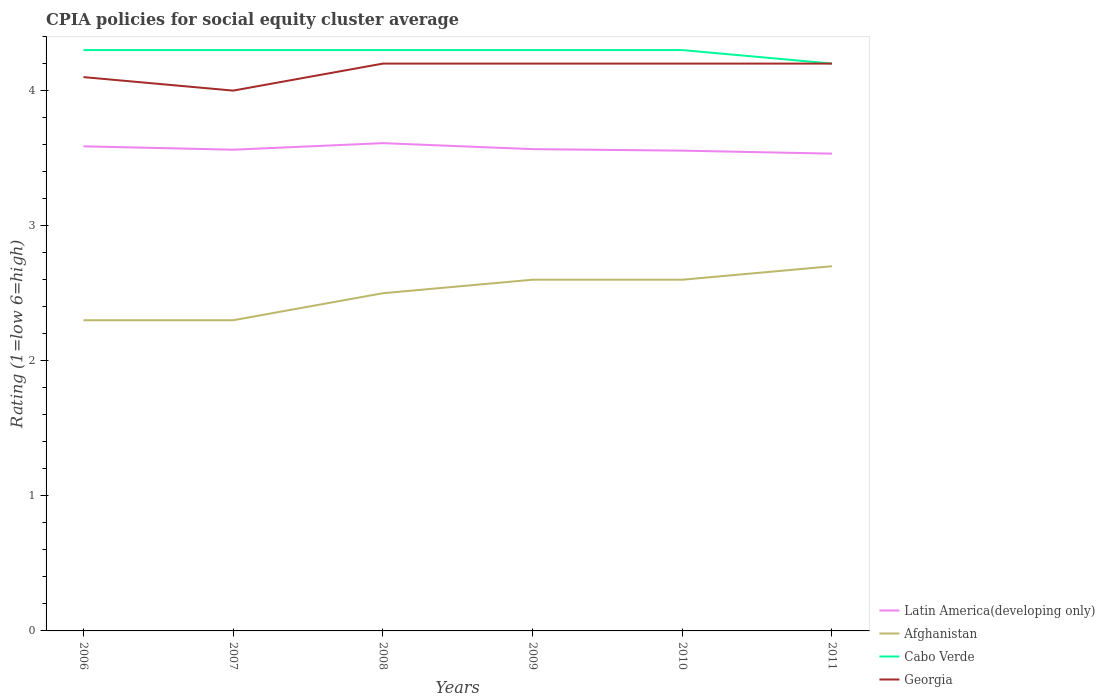How many different coloured lines are there?
Offer a terse response. 4. Does the line corresponding to Latin America(developing only) intersect with the line corresponding to Cabo Verde?
Your answer should be very brief. No. Is the number of lines equal to the number of legend labels?
Offer a terse response. Yes. Across all years, what is the maximum CPIA rating in Georgia?
Provide a succinct answer. 4. What is the difference between the highest and the second highest CPIA rating in Georgia?
Offer a terse response. 0.2. What is the difference between the highest and the lowest CPIA rating in Afghanistan?
Keep it short and to the point. 3. Is the CPIA rating in Cabo Verde strictly greater than the CPIA rating in Georgia over the years?
Ensure brevity in your answer.  No. How many lines are there?
Offer a terse response. 4. Are the values on the major ticks of Y-axis written in scientific E-notation?
Provide a short and direct response. No. Does the graph contain grids?
Your response must be concise. No. Where does the legend appear in the graph?
Provide a succinct answer. Bottom right. What is the title of the graph?
Your answer should be compact. CPIA policies for social equity cluster average. Does "Kuwait" appear as one of the legend labels in the graph?
Make the answer very short. No. What is the label or title of the Y-axis?
Offer a very short reply. Rating (1=low 6=high). What is the Rating (1=low 6=high) in Latin America(developing only) in 2006?
Your answer should be compact. 3.59. What is the Rating (1=low 6=high) in Latin America(developing only) in 2007?
Ensure brevity in your answer.  3.56. What is the Rating (1=low 6=high) in Cabo Verde in 2007?
Your response must be concise. 4.3. What is the Rating (1=low 6=high) in Latin America(developing only) in 2008?
Provide a short and direct response. 3.61. What is the Rating (1=low 6=high) in Afghanistan in 2008?
Offer a terse response. 2.5. What is the Rating (1=low 6=high) in Georgia in 2008?
Provide a short and direct response. 4.2. What is the Rating (1=low 6=high) of Latin America(developing only) in 2009?
Offer a very short reply. 3.57. What is the Rating (1=low 6=high) of Afghanistan in 2009?
Keep it short and to the point. 2.6. What is the Rating (1=low 6=high) of Cabo Verde in 2009?
Keep it short and to the point. 4.3. What is the Rating (1=low 6=high) in Georgia in 2009?
Give a very brief answer. 4.2. What is the Rating (1=low 6=high) in Latin America(developing only) in 2010?
Offer a terse response. 3.56. What is the Rating (1=low 6=high) in Cabo Verde in 2010?
Make the answer very short. 4.3. What is the Rating (1=low 6=high) of Georgia in 2010?
Provide a short and direct response. 4.2. What is the Rating (1=low 6=high) of Latin America(developing only) in 2011?
Provide a succinct answer. 3.53. What is the Rating (1=low 6=high) in Afghanistan in 2011?
Keep it short and to the point. 2.7. What is the Rating (1=low 6=high) of Cabo Verde in 2011?
Provide a succinct answer. 4.2. What is the Rating (1=low 6=high) in Georgia in 2011?
Give a very brief answer. 4.2. Across all years, what is the maximum Rating (1=low 6=high) of Latin America(developing only)?
Make the answer very short. 3.61. Across all years, what is the maximum Rating (1=low 6=high) of Afghanistan?
Your response must be concise. 2.7. Across all years, what is the minimum Rating (1=low 6=high) of Latin America(developing only)?
Your answer should be very brief. 3.53. Across all years, what is the minimum Rating (1=low 6=high) of Cabo Verde?
Your answer should be very brief. 4.2. Across all years, what is the minimum Rating (1=low 6=high) of Georgia?
Provide a short and direct response. 4. What is the total Rating (1=low 6=high) in Latin America(developing only) in the graph?
Your response must be concise. 21.42. What is the total Rating (1=low 6=high) of Afghanistan in the graph?
Offer a terse response. 15. What is the total Rating (1=low 6=high) in Cabo Verde in the graph?
Give a very brief answer. 25.7. What is the total Rating (1=low 6=high) of Georgia in the graph?
Offer a terse response. 24.9. What is the difference between the Rating (1=low 6=high) of Latin America(developing only) in 2006 and that in 2007?
Your answer should be very brief. 0.03. What is the difference between the Rating (1=low 6=high) of Georgia in 2006 and that in 2007?
Give a very brief answer. 0.1. What is the difference between the Rating (1=low 6=high) in Latin America(developing only) in 2006 and that in 2008?
Your answer should be compact. -0.02. What is the difference between the Rating (1=low 6=high) of Cabo Verde in 2006 and that in 2008?
Your answer should be compact. 0. What is the difference between the Rating (1=low 6=high) in Latin America(developing only) in 2006 and that in 2009?
Your response must be concise. 0.02. What is the difference between the Rating (1=low 6=high) of Cabo Verde in 2006 and that in 2009?
Your answer should be very brief. 0. What is the difference between the Rating (1=low 6=high) of Georgia in 2006 and that in 2009?
Your response must be concise. -0.1. What is the difference between the Rating (1=low 6=high) in Latin America(developing only) in 2006 and that in 2010?
Provide a short and direct response. 0.03. What is the difference between the Rating (1=low 6=high) of Afghanistan in 2006 and that in 2010?
Your response must be concise. -0.3. What is the difference between the Rating (1=low 6=high) of Latin America(developing only) in 2006 and that in 2011?
Your answer should be very brief. 0.05. What is the difference between the Rating (1=low 6=high) of Afghanistan in 2006 and that in 2011?
Offer a very short reply. -0.4. What is the difference between the Rating (1=low 6=high) of Cabo Verde in 2006 and that in 2011?
Your answer should be very brief. 0.1. What is the difference between the Rating (1=low 6=high) of Georgia in 2006 and that in 2011?
Your answer should be compact. -0.1. What is the difference between the Rating (1=low 6=high) of Latin America(developing only) in 2007 and that in 2008?
Ensure brevity in your answer.  -0.05. What is the difference between the Rating (1=low 6=high) in Afghanistan in 2007 and that in 2008?
Make the answer very short. -0.2. What is the difference between the Rating (1=low 6=high) in Latin America(developing only) in 2007 and that in 2009?
Offer a terse response. -0. What is the difference between the Rating (1=low 6=high) in Afghanistan in 2007 and that in 2009?
Ensure brevity in your answer.  -0.3. What is the difference between the Rating (1=low 6=high) of Georgia in 2007 and that in 2009?
Offer a terse response. -0.2. What is the difference between the Rating (1=low 6=high) of Latin America(developing only) in 2007 and that in 2010?
Provide a succinct answer. 0.01. What is the difference between the Rating (1=low 6=high) of Afghanistan in 2007 and that in 2010?
Your answer should be compact. -0.3. What is the difference between the Rating (1=low 6=high) in Cabo Verde in 2007 and that in 2010?
Give a very brief answer. 0. What is the difference between the Rating (1=low 6=high) of Georgia in 2007 and that in 2010?
Offer a terse response. -0.2. What is the difference between the Rating (1=low 6=high) in Latin America(developing only) in 2007 and that in 2011?
Your response must be concise. 0.03. What is the difference between the Rating (1=low 6=high) in Afghanistan in 2007 and that in 2011?
Keep it short and to the point. -0.4. What is the difference between the Rating (1=low 6=high) in Georgia in 2007 and that in 2011?
Offer a terse response. -0.2. What is the difference between the Rating (1=low 6=high) of Latin America(developing only) in 2008 and that in 2009?
Provide a short and direct response. 0.04. What is the difference between the Rating (1=low 6=high) in Cabo Verde in 2008 and that in 2009?
Your response must be concise. 0. What is the difference between the Rating (1=low 6=high) in Latin America(developing only) in 2008 and that in 2010?
Your response must be concise. 0.06. What is the difference between the Rating (1=low 6=high) of Afghanistan in 2008 and that in 2010?
Provide a succinct answer. -0.1. What is the difference between the Rating (1=low 6=high) of Georgia in 2008 and that in 2010?
Keep it short and to the point. 0. What is the difference between the Rating (1=low 6=high) of Latin America(developing only) in 2008 and that in 2011?
Give a very brief answer. 0.08. What is the difference between the Rating (1=low 6=high) in Afghanistan in 2008 and that in 2011?
Ensure brevity in your answer.  -0.2. What is the difference between the Rating (1=low 6=high) of Georgia in 2008 and that in 2011?
Make the answer very short. 0. What is the difference between the Rating (1=low 6=high) in Latin America(developing only) in 2009 and that in 2010?
Your answer should be compact. 0.01. What is the difference between the Rating (1=low 6=high) of Afghanistan in 2009 and that in 2010?
Your answer should be very brief. 0. What is the difference between the Rating (1=low 6=high) in Cabo Verde in 2009 and that in 2010?
Keep it short and to the point. 0. What is the difference between the Rating (1=low 6=high) in Latin America(developing only) in 2010 and that in 2011?
Make the answer very short. 0.02. What is the difference between the Rating (1=low 6=high) of Latin America(developing only) in 2006 and the Rating (1=low 6=high) of Afghanistan in 2007?
Offer a terse response. 1.29. What is the difference between the Rating (1=low 6=high) in Latin America(developing only) in 2006 and the Rating (1=low 6=high) in Cabo Verde in 2007?
Ensure brevity in your answer.  -0.71. What is the difference between the Rating (1=low 6=high) in Latin America(developing only) in 2006 and the Rating (1=low 6=high) in Georgia in 2007?
Provide a succinct answer. -0.41. What is the difference between the Rating (1=low 6=high) in Afghanistan in 2006 and the Rating (1=low 6=high) in Cabo Verde in 2007?
Ensure brevity in your answer.  -2. What is the difference between the Rating (1=low 6=high) in Afghanistan in 2006 and the Rating (1=low 6=high) in Georgia in 2007?
Keep it short and to the point. -1.7. What is the difference between the Rating (1=low 6=high) of Cabo Verde in 2006 and the Rating (1=low 6=high) of Georgia in 2007?
Make the answer very short. 0.3. What is the difference between the Rating (1=low 6=high) of Latin America(developing only) in 2006 and the Rating (1=low 6=high) of Afghanistan in 2008?
Ensure brevity in your answer.  1.09. What is the difference between the Rating (1=low 6=high) in Latin America(developing only) in 2006 and the Rating (1=low 6=high) in Cabo Verde in 2008?
Ensure brevity in your answer.  -0.71. What is the difference between the Rating (1=low 6=high) of Latin America(developing only) in 2006 and the Rating (1=low 6=high) of Georgia in 2008?
Offer a terse response. -0.61. What is the difference between the Rating (1=low 6=high) in Afghanistan in 2006 and the Rating (1=low 6=high) in Cabo Verde in 2008?
Offer a terse response. -2. What is the difference between the Rating (1=low 6=high) in Afghanistan in 2006 and the Rating (1=low 6=high) in Georgia in 2008?
Your answer should be very brief. -1.9. What is the difference between the Rating (1=low 6=high) of Cabo Verde in 2006 and the Rating (1=low 6=high) of Georgia in 2008?
Your answer should be compact. 0.1. What is the difference between the Rating (1=low 6=high) in Latin America(developing only) in 2006 and the Rating (1=low 6=high) in Afghanistan in 2009?
Ensure brevity in your answer.  0.99. What is the difference between the Rating (1=low 6=high) of Latin America(developing only) in 2006 and the Rating (1=low 6=high) of Cabo Verde in 2009?
Give a very brief answer. -0.71. What is the difference between the Rating (1=low 6=high) of Latin America(developing only) in 2006 and the Rating (1=low 6=high) of Georgia in 2009?
Give a very brief answer. -0.61. What is the difference between the Rating (1=low 6=high) in Latin America(developing only) in 2006 and the Rating (1=low 6=high) in Afghanistan in 2010?
Keep it short and to the point. 0.99. What is the difference between the Rating (1=low 6=high) of Latin America(developing only) in 2006 and the Rating (1=low 6=high) of Cabo Verde in 2010?
Give a very brief answer. -0.71. What is the difference between the Rating (1=low 6=high) in Latin America(developing only) in 2006 and the Rating (1=low 6=high) in Georgia in 2010?
Ensure brevity in your answer.  -0.61. What is the difference between the Rating (1=low 6=high) in Afghanistan in 2006 and the Rating (1=low 6=high) in Cabo Verde in 2010?
Your response must be concise. -2. What is the difference between the Rating (1=low 6=high) in Cabo Verde in 2006 and the Rating (1=low 6=high) in Georgia in 2010?
Provide a short and direct response. 0.1. What is the difference between the Rating (1=low 6=high) of Latin America(developing only) in 2006 and the Rating (1=low 6=high) of Afghanistan in 2011?
Give a very brief answer. 0.89. What is the difference between the Rating (1=low 6=high) of Latin America(developing only) in 2006 and the Rating (1=low 6=high) of Cabo Verde in 2011?
Your answer should be very brief. -0.61. What is the difference between the Rating (1=low 6=high) of Latin America(developing only) in 2006 and the Rating (1=low 6=high) of Georgia in 2011?
Make the answer very short. -0.61. What is the difference between the Rating (1=low 6=high) in Afghanistan in 2006 and the Rating (1=low 6=high) in Cabo Verde in 2011?
Your answer should be compact. -1.9. What is the difference between the Rating (1=low 6=high) in Afghanistan in 2006 and the Rating (1=low 6=high) in Georgia in 2011?
Give a very brief answer. -1.9. What is the difference between the Rating (1=low 6=high) of Cabo Verde in 2006 and the Rating (1=low 6=high) of Georgia in 2011?
Your answer should be very brief. 0.1. What is the difference between the Rating (1=low 6=high) of Latin America(developing only) in 2007 and the Rating (1=low 6=high) of Afghanistan in 2008?
Offer a very short reply. 1.06. What is the difference between the Rating (1=low 6=high) in Latin America(developing only) in 2007 and the Rating (1=low 6=high) in Cabo Verde in 2008?
Your answer should be very brief. -0.74. What is the difference between the Rating (1=low 6=high) of Latin America(developing only) in 2007 and the Rating (1=low 6=high) of Georgia in 2008?
Offer a very short reply. -0.64. What is the difference between the Rating (1=low 6=high) of Afghanistan in 2007 and the Rating (1=low 6=high) of Cabo Verde in 2008?
Offer a terse response. -2. What is the difference between the Rating (1=low 6=high) of Latin America(developing only) in 2007 and the Rating (1=low 6=high) of Afghanistan in 2009?
Provide a short and direct response. 0.96. What is the difference between the Rating (1=low 6=high) of Latin America(developing only) in 2007 and the Rating (1=low 6=high) of Cabo Verde in 2009?
Make the answer very short. -0.74. What is the difference between the Rating (1=low 6=high) in Latin America(developing only) in 2007 and the Rating (1=low 6=high) in Georgia in 2009?
Provide a short and direct response. -0.64. What is the difference between the Rating (1=low 6=high) of Afghanistan in 2007 and the Rating (1=low 6=high) of Georgia in 2009?
Ensure brevity in your answer.  -1.9. What is the difference between the Rating (1=low 6=high) in Latin America(developing only) in 2007 and the Rating (1=low 6=high) in Afghanistan in 2010?
Provide a short and direct response. 0.96. What is the difference between the Rating (1=low 6=high) in Latin America(developing only) in 2007 and the Rating (1=low 6=high) in Cabo Verde in 2010?
Provide a succinct answer. -0.74. What is the difference between the Rating (1=low 6=high) of Latin America(developing only) in 2007 and the Rating (1=low 6=high) of Georgia in 2010?
Keep it short and to the point. -0.64. What is the difference between the Rating (1=low 6=high) in Afghanistan in 2007 and the Rating (1=low 6=high) in Cabo Verde in 2010?
Provide a short and direct response. -2. What is the difference between the Rating (1=low 6=high) in Cabo Verde in 2007 and the Rating (1=low 6=high) in Georgia in 2010?
Offer a very short reply. 0.1. What is the difference between the Rating (1=low 6=high) of Latin America(developing only) in 2007 and the Rating (1=low 6=high) of Afghanistan in 2011?
Keep it short and to the point. 0.86. What is the difference between the Rating (1=low 6=high) in Latin America(developing only) in 2007 and the Rating (1=low 6=high) in Cabo Verde in 2011?
Make the answer very short. -0.64. What is the difference between the Rating (1=low 6=high) of Latin America(developing only) in 2007 and the Rating (1=low 6=high) of Georgia in 2011?
Offer a very short reply. -0.64. What is the difference between the Rating (1=low 6=high) of Afghanistan in 2007 and the Rating (1=low 6=high) of Cabo Verde in 2011?
Offer a terse response. -1.9. What is the difference between the Rating (1=low 6=high) in Afghanistan in 2007 and the Rating (1=low 6=high) in Georgia in 2011?
Your answer should be compact. -1.9. What is the difference between the Rating (1=low 6=high) in Latin America(developing only) in 2008 and the Rating (1=low 6=high) in Afghanistan in 2009?
Provide a short and direct response. 1.01. What is the difference between the Rating (1=low 6=high) in Latin America(developing only) in 2008 and the Rating (1=low 6=high) in Cabo Verde in 2009?
Make the answer very short. -0.69. What is the difference between the Rating (1=low 6=high) of Latin America(developing only) in 2008 and the Rating (1=low 6=high) of Georgia in 2009?
Your answer should be very brief. -0.59. What is the difference between the Rating (1=low 6=high) of Afghanistan in 2008 and the Rating (1=low 6=high) of Cabo Verde in 2009?
Your answer should be compact. -1.8. What is the difference between the Rating (1=low 6=high) in Afghanistan in 2008 and the Rating (1=low 6=high) in Georgia in 2009?
Provide a short and direct response. -1.7. What is the difference between the Rating (1=low 6=high) of Cabo Verde in 2008 and the Rating (1=low 6=high) of Georgia in 2009?
Your answer should be very brief. 0.1. What is the difference between the Rating (1=low 6=high) in Latin America(developing only) in 2008 and the Rating (1=low 6=high) in Afghanistan in 2010?
Provide a succinct answer. 1.01. What is the difference between the Rating (1=low 6=high) in Latin America(developing only) in 2008 and the Rating (1=low 6=high) in Cabo Verde in 2010?
Make the answer very short. -0.69. What is the difference between the Rating (1=low 6=high) of Latin America(developing only) in 2008 and the Rating (1=low 6=high) of Georgia in 2010?
Provide a succinct answer. -0.59. What is the difference between the Rating (1=low 6=high) of Afghanistan in 2008 and the Rating (1=low 6=high) of Cabo Verde in 2010?
Provide a short and direct response. -1.8. What is the difference between the Rating (1=low 6=high) of Cabo Verde in 2008 and the Rating (1=low 6=high) of Georgia in 2010?
Give a very brief answer. 0.1. What is the difference between the Rating (1=low 6=high) of Latin America(developing only) in 2008 and the Rating (1=low 6=high) of Afghanistan in 2011?
Your answer should be very brief. 0.91. What is the difference between the Rating (1=low 6=high) in Latin America(developing only) in 2008 and the Rating (1=low 6=high) in Cabo Verde in 2011?
Give a very brief answer. -0.59. What is the difference between the Rating (1=low 6=high) in Latin America(developing only) in 2008 and the Rating (1=low 6=high) in Georgia in 2011?
Your answer should be very brief. -0.59. What is the difference between the Rating (1=low 6=high) in Cabo Verde in 2008 and the Rating (1=low 6=high) in Georgia in 2011?
Your response must be concise. 0.1. What is the difference between the Rating (1=low 6=high) of Latin America(developing only) in 2009 and the Rating (1=low 6=high) of Afghanistan in 2010?
Keep it short and to the point. 0.97. What is the difference between the Rating (1=low 6=high) of Latin America(developing only) in 2009 and the Rating (1=low 6=high) of Cabo Verde in 2010?
Provide a short and direct response. -0.73. What is the difference between the Rating (1=low 6=high) of Latin America(developing only) in 2009 and the Rating (1=low 6=high) of Georgia in 2010?
Keep it short and to the point. -0.63. What is the difference between the Rating (1=low 6=high) in Latin America(developing only) in 2009 and the Rating (1=low 6=high) in Afghanistan in 2011?
Your response must be concise. 0.87. What is the difference between the Rating (1=low 6=high) of Latin America(developing only) in 2009 and the Rating (1=low 6=high) of Cabo Verde in 2011?
Make the answer very short. -0.63. What is the difference between the Rating (1=low 6=high) of Latin America(developing only) in 2009 and the Rating (1=low 6=high) of Georgia in 2011?
Provide a short and direct response. -0.63. What is the difference between the Rating (1=low 6=high) in Afghanistan in 2009 and the Rating (1=low 6=high) in Georgia in 2011?
Your response must be concise. -1.6. What is the difference between the Rating (1=low 6=high) of Cabo Verde in 2009 and the Rating (1=low 6=high) of Georgia in 2011?
Give a very brief answer. 0.1. What is the difference between the Rating (1=low 6=high) in Latin America(developing only) in 2010 and the Rating (1=low 6=high) in Afghanistan in 2011?
Your response must be concise. 0.86. What is the difference between the Rating (1=low 6=high) in Latin America(developing only) in 2010 and the Rating (1=low 6=high) in Cabo Verde in 2011?
Provide a succinct answer. -0.64. What is the difference between the Rating (1=low 6=high) in Latin America(developing only) in 2010 and the Rating (1=low 6=high) in Georgia in 2011?
Your answer should be very brief. -0.64. What is the difference between the Rating (1=low 6=high) in Afghanistan in 2010 and the Rating (1=low 6=high) in Georgia in 2011?
Provide a succinct answer. -1.6. What is the average Rating (1=low 6=high) of Latin America(developing only) per year?
Provide a succinct answer. 3.57. What is the average Rating (1=low 6=high) of Afghanistan per year?
Your answer should be compact. 2.5. What is the average Rating (1=low 6=high) of Cabo Verde per year?
Make the answer very short. 4.28. What is the average Rating (1=low 6=high) in Georgia per year?
Offer a terse response. 4.15. In the year 2006, what is the difference between the Rating (1=low 6=high) of Latin America(developing only) and Rating (1=low 6=high) of Afghanistan?
Your answer should be compact. 1.29. In the year 2006, what is the difference between the Rating (1=low 6=high) in Latin America(developing only) and Rating (1=low 6=high) in Cabo Verde?
Make the answer very short. -0.71. In the year 2006, what is the difference between the Rating (1=low 6=high) of Latin America(developing only) and Rating (1=low 6=high) of Georgia?
Keep it short and to the point. -0.51. In the year 2006, what is the difference between the Rating (1=low 6=high) in Afghanistan and Rating (1=low 6=high) in Cabo Verde?
Keep it short and to the point. -2. In the year 2006, what is the difference between the Rating (1=low 6=high) of Cabo Verde and Rating (1=low 6=high) of Georgia?
Your response must be concise. 0.2. In the year 2007, what is the difference between the Rating (1=low 6=high) in Latin America(developing only) and Rating (1=low 6=high) in Afghanistan?
Provide a short and direct response. 1.26. In the year 2007, what is the difference between the Rating (1=low 6=high) in Latin America(developing only) and Rating (1=low 6=high) in Cabo Verde?
Your answer should be very brief. -0.74. In the year 2007, what is the difference between the Rating (1=low 6=high) of Latin America(developing only) and Rating (1=low 6=high) of Georgia?
Provide a succinct answer. -0.44. In the year 2007, what is the difference between the Rating (1=low 6=high) of Afghanistan and Rating (1=low 6=high) of Georgia?
Provide a succinct answer. -1.7. In the year 2008, what is the difference between the Rating (1=low 6=high) in Latin America(developing only) and Rating (1=low 6=high) in Afghanistan?
Offer a very short reply. 1.11. In the year 2008, what is the difference between the Rating (1=low 6=high) in Latin America(developing only) and Rating (1=low 6=high) in Cabo Verde?
Keep it short and to the point. -0.69. In the year 2008, what is the difference between the Rating (1=low 6=high) in Latin America(developing only) and Rating (1=low 6=high) in Georgia?
Provide a short and direct response. -0.59. In the year 2008, what is the difference between the Rating (1=low 6=high) of Afghanistan and Rating (1=low 6=high) of Georgia?
Offer a very short reply. -1.7. In the year 2008, what is the difference between the Rating (1=low 6=high) in Cabo Verde and Rating (1=low 6=high) in Georgia?
Ensure brevity in your answer.  0.1. In the year 2009, what is the difference between the Rating (1=low 6=high) of Latin America(developing only) and Rating (1=low 6=high) of Afghanistan?
Make the answer very short. 0.97. In the year 2009, what is the difference between the Rating (1=low 6=high) in Latin America(developing only) and Rating (1=low 6=high) in Cabo Verde?
Provide a short and direct response. -0.73. In the year 2009, what is the difference between the Rating (1=low 6=high) of Latin America(developing only) and Rating (1=low 6=high) of Georgia?
Offer a very short reply. -0.63. In the year 2009, what is the difference between the Rating (1=low 6=high) in Afghanistan and Rating (1=low 6=high) in Cabo Verde?
Offer a very short reply. -1.7. In the year 2009, what is the difference between the Rating (1=low 6=high) in Afghanistan and Rating (1=low 6=high) in Georgia?
Keep it short and to the point. -1.6. In the year 2009, what is the difference between the Rating (1=low 6=high) in Cabo Verde and Rating (1=low 6=high) in Georgia?
Ensure brevity in your answer.  0.1. In the year 2010, what is the difference between the Rating (1=low 6=high) in Latin America(developing only) and Rating (1=low 6=high) in Afghanistan?
Offer a very short reply. 0.96. In the year 2010, what is the difference between the Rating (1=low 6=high) of Latin America(developing only) and Rating (1=low 6=high) of Cabo Verde?
Your answer should be compact. -0.74. In the year 2010, what is the difference between the Rating (1=low 6=high) of Latin America(developing only) and Rating (1=low 6=high) of Georgia?
Your response must be concise. -0.64. In the year 2011, what is the difference between the Rating (1=low 6=high) of Latin America(developing only) and Rating (1=low 6=high) of Afghanistan?
Provide a succinct answer. 0.83. In the year 2011, what is the difference between the Rating (1=low 6=high) of Afghanistan and Rating (1=low 6=high) of Georgia?
Provide a short and direct response. -1.5. What is the ratio of the Rating (1=low 6=high) in Afghanistan in 2006 to that in 2007?
Keep it short and to the point. 1. What is the ratio of the Rating (1=low 6=high) of Afghanistan in 2006 to that in 2008?
Keep it short and to the point. 0.92. What is the ratio of the Rating (1=low 6=high) of Cabo Verde in 2006 to that in 2008?
Your response must be concise. 1. What is the ratio of the Rating (1=low 6=high) in Georgia in 2006 to that in 2008?
Give a very brief answer. 0.98. What is the ratio of the Rating (1=low 6=high) of Afghanistan in 2006 to that in 2009?
Offer a very short reply. 0.88. What is the ratio of the Rating (1=low 6=high) of Georgia in 2006 to that in 2009?
Your answer should be very brief. 0.98. What is the ratio of the Rating (1=low 6=high) in Afghanistan in 2006 to that in 2010?
Ensure brevity in your answer.  0.88. What is the ratio of the Rating (1=low 6=high) of Cabo Verde in 2006 to that in 2010?
Offer a very short reply. 1. What is the ratio of the Rating (1=low 6=high) in Georgia in 2006 to that in 2010?
Give a very brief answer. 0.98. What is the ratio of the Rating (1=low 6=high) in Latin America(developing only) in 2006 to that in 2011?
Your response must be concise. 1.02. What is the ratio of the Rating (1=low 6=high) in Afghanistan in 2006 to that in 2011?
Keep it short and to the point. 0.85. What is the ratio of the Rating (1=low 6=high) in Cabo Verde in 2006 to that in 2011?
Ensure brevity in your answer.  1.02. What is the ratio of the Rating (1=low 6=high) of Georgia in 2006 to that in 2011?
Ensure brevity in your answer.  0.98. What is the ratio of the Rating (1=low 6=high) in Latin America(developing only) in 2007 to that in 2008?
Your answer should be compact. 0.99. What is the ratio of the Rating (1=low 6=high) of Afghanistan in 2007 to that in 2008?
Your answer should be compact. 0.92. What is the ratio of the Rating (1=low 6=high) in Cabo Verde in 2007 to that in 2008?
Give a very brief answer. 1. What is the ratio of the Rating (1=low 6=high) in Georgia in 2007 to that in 2008?
Provide a short and direct response. 0.95. What is the ratio of the Rating (1=low 6=high) in Afghanistan in 2007 to that in 2009?
Give a very brief answer. 0.88. What is the ratio of the Rating (1=low 6=high) in Georgia in 2007 to that in 2009?
Provide a succinct answer. 0.95. What is the ratio of the Rating (1=low 6=high) of Afghanistan in 2007 to that in 2010?
Provide a succinct answer. 0.88. What is the ratio of the Rating (1=low 6=high) of Latin America(developing only) in 2007 to that in 2011?
Keep it short and to the point. 1.01. What is the ratio of the Rating (1=low 6=high) of Afghanistan in 2007 to that in 2011?
Your answer should be very brief. 0.85. What is the ratio of the Rating (1=low 6=high) of Cabo Verde in 2007 to that in 2011?
Offer a very short reply. 1.02. What is the ratio of the Rating (1=low 6=high) of Georgia in 2007 to that in 2011?
Provide a short and direct response. 0.95. What is the ratio of the Rating (1=low 6=high) in Latin America(developing only) in 2008 to that in 2009?
Ensure brevity in your answer.  1.01. What is the ratio of the Rating (1=low 6=high) in Afghanistan in 2008 to that in 2009?
Ensure brevity in your answer.  0.96. What is the ratio of the Rating (1=low 6=high) in Latin America(developing only) in 2008 to that in 2010?
Offer a terse response. 1.02. What is the ratio of the Rating (1=low 6=high) in Afghanistan in 2008 to that in 2010?
Offer a terse response. 0.96. What is the ratio of the Rating (1=low 6=high) in Latin America(developing only) in 2008 to that in 2011?
Offer a very short reply. 1.02. What is the ratio of the Rating (1=low 6=high) in Afghanistan in 2008 to that in 2011?
Make the answer very short. 0.93. What is the ratio of the Rating (1=low 6=high) in Cabo Verde in 2008 to that in 2011?
Give a very brief answer. 1.02. What is the ratio of the Rating (1=low 6=high) of Georgia in 2008 to that in 2011?
Provide a short and direct response. 1. What is the ratio of the Rating (1=low 6=high) in Afghanistan in 2009 to that in 2010?
Your answer should be compact. 1. What is the ratio of the Rating (1=low 6=high) in Cabo Verde in 2009 to that in 2010?
Keep it short and to the point. 1. What is the ratio of the Rating (1=low 6=high) of Latin America(developing only) in 2009 to that in 2011?
Provide a succinct answer. 1.01. What is the ratio of the Rating (1=low 6=high) in Afghanistan in 2009 to that in 2011?
Give a very brief answer. 0.96. What is the ratio of the Rating (1=low 6=high) in Cabo Verde in 2009 to that in 2011?
Offer a very short reply. 1.02. What is the ratio of the Rating (1=low 6=high) in Georgia in 2009 to that in 2011?
Give a very brief answer. 1. What is the ratio of the Rating (1=low 6=high) in Afghanistan in 2010 to that in 2011?
Provide a short and direct response. 0.96. What is the ratio of the Rating (1=low 6=high) in Cabo Verde in 2010 to that in 2011?
Ensure brevity in your answer.  1.02. What is the difference between the highest and the second highest Rating (1=low 6=high) of Latin America(developing only)?
Give a very brief answer. 0.02. What is the difference between the highest and the lowest Rating (1=low 6=high) of Latin America(developing only)?
Offer a very short reply. 0.08. What is the difference between the highest and the lowest Rating (1=low 6=high) of Afghanistan?
Provide a short and direct response. 0.4. What is the difference between the highest and the lowest Rating (1=low 6=high) of Cabo Verde?
Offer a terse response. 0.1. 